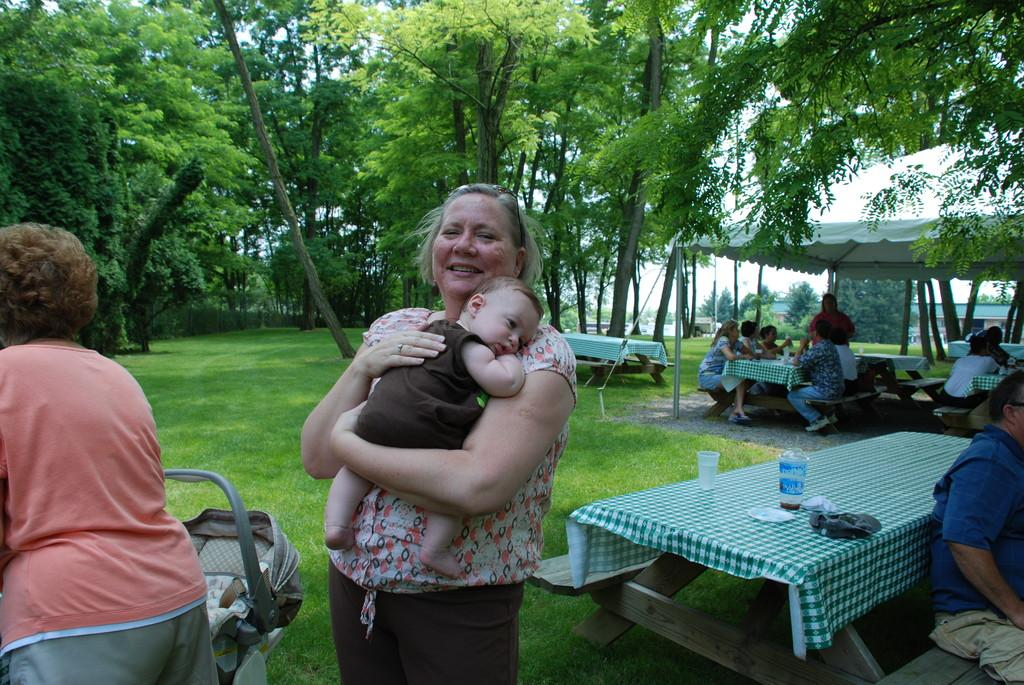Who is the main subject in the image? There is a woman in the image. What is the woman doing in the image? The woman is holding a baby. What can be seen in the background of the image? There are trees visible in the background. Are there any other people in the image besides the woman and the baby? Yes, people are sitting on chairs in the background. What type of popcorn is being served to the people sitting on chairs in the image? There is no popcorn present in the image; it only shows a woman holding a baby and people sitting on chairs in the background. 